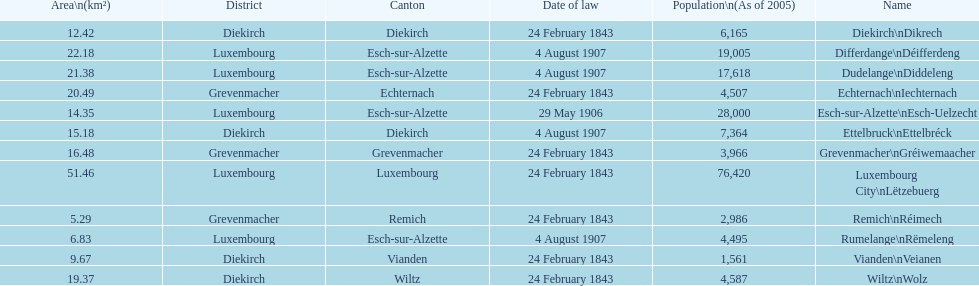Which canton falls under the date of law of 24 february 1843 and has a population of 3,966? Grevenmacher. 